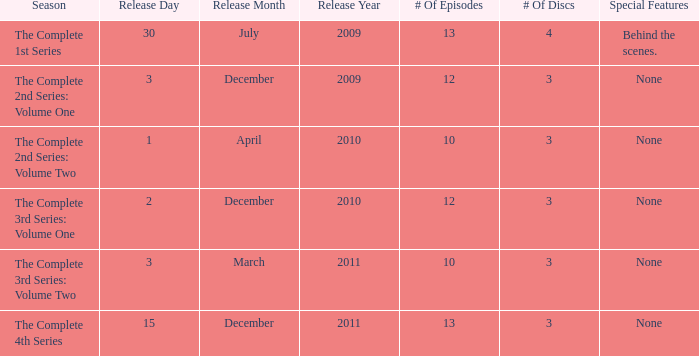Can you parse all the data within this table? {'header': ['Season', 'Release Day', 'Release Month', 'Release Year', '# Of Episodes', '# Of Discs', 'Special Features'], 'rows': [['The Complete 1st Series', '30', 'July', '2009', '13', '4', 'Behind the scenes.'], ['The Complete 2nd Series: Volume One', '3', 'December', '2009', '12', '3', 'None'], ['The Complete 2nd Series: Volume Two', '1', 'April', '2010', '10', '3', 'None'], ['The Complete 3rd Series: Volume One', '2', 'December', '2010', '12', '3', 'None'], ['The Complete 3rd Series: Volume Two', '3', 'March', '2011', '10', '3', 'None'], ['The Complete 4th Series', '15', 'December', '2011', '13', '3', 'None']]} How many discs for the complete 4th series? 3.0. 